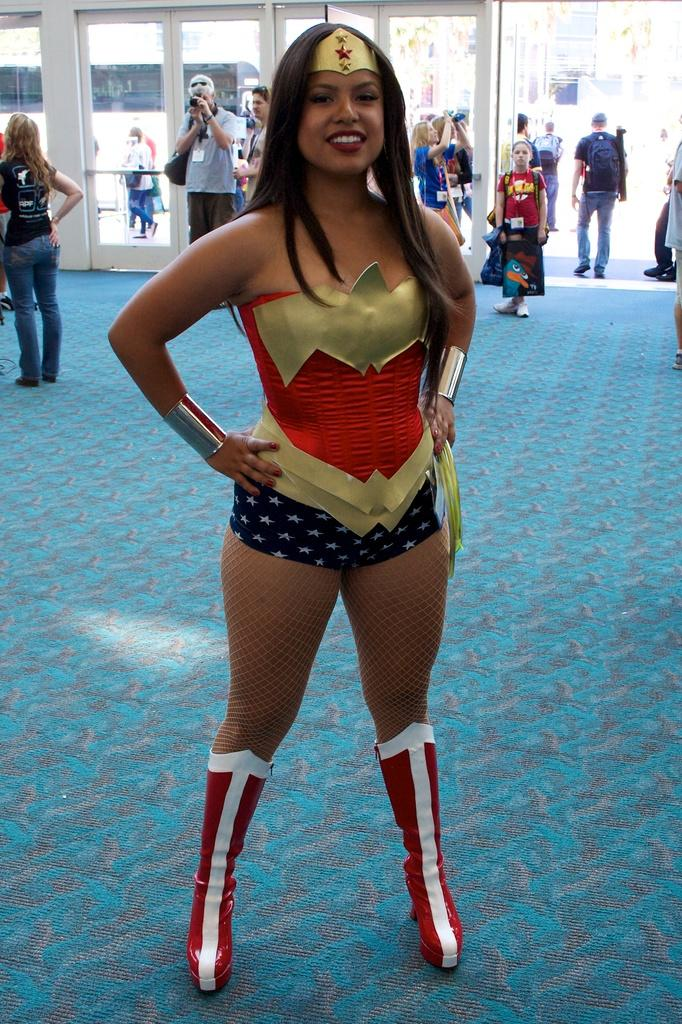What is the main subject of the image? There is a woman standing in the image. Can you describe the surroundings of the woman? There are people visible in the background of the image. What type of agreement is the scarecrow making with the woman in the image? There is no scarecrow present in the image, so it is not possible to determine any agreements made. 